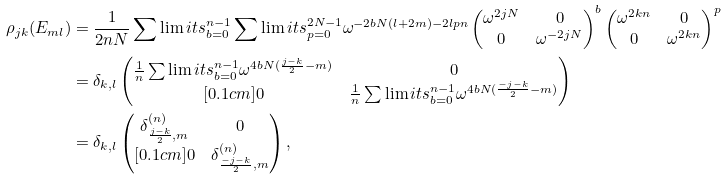<formula> <loc_0><loc_0><loc_500><loc_500>\rho _ { j k } ( E _ { m l } ) & = \frac { 1 } { 2 n N } \sum \lim i t s _ { b = 0 } ^ { n - 1 } \sum \lim i t s _ { p = 0 } ^ { 2 N - 1 } \omega ^ { - 2 b N ( l + 2 m ) - 2 l p n } \begin{pmatrix} \omega ^ { 2 j N } & 0 \\ 0 & \omega ^ { - 2 j N } \end{pmatrix} ^ { b } \begin{pmatrix} \omega ^ { 2 k n } & 0 \\ 0 & \omega ^ { 2 k n } \end{pmatrix} ^ { p } \\ & = \delta _ { k , l } \begin{pmatrix} \frac { 1 } { n } \sum \lim i t s _ { b = 0 } ^ { n - 1 } \omega ^ { 4 b N ( \frac { j - k } { 2 } - m ) } & 0 \\ [ 0 . 1 c m ] 0 & \frac { 1 } { n } \sum \lim i t s _ { b = 0 } ^ { n - 1 } \omega ^ { 4 b N ( \frac { - j - k } { 2 } - m ) } \end{pmatrix} \\ & = \delta _ { k , l } \begin{pmatrix} \delta _ { \frac { j - k } { 2 } , m } ^ { ( n ) } & 0 \\ [ 0 . 1 c m ] 0 & \delta _ { \frac { - j - k } { 2 } , m } ^ { ( n ) } \end{pmatrix} ,</formula> 